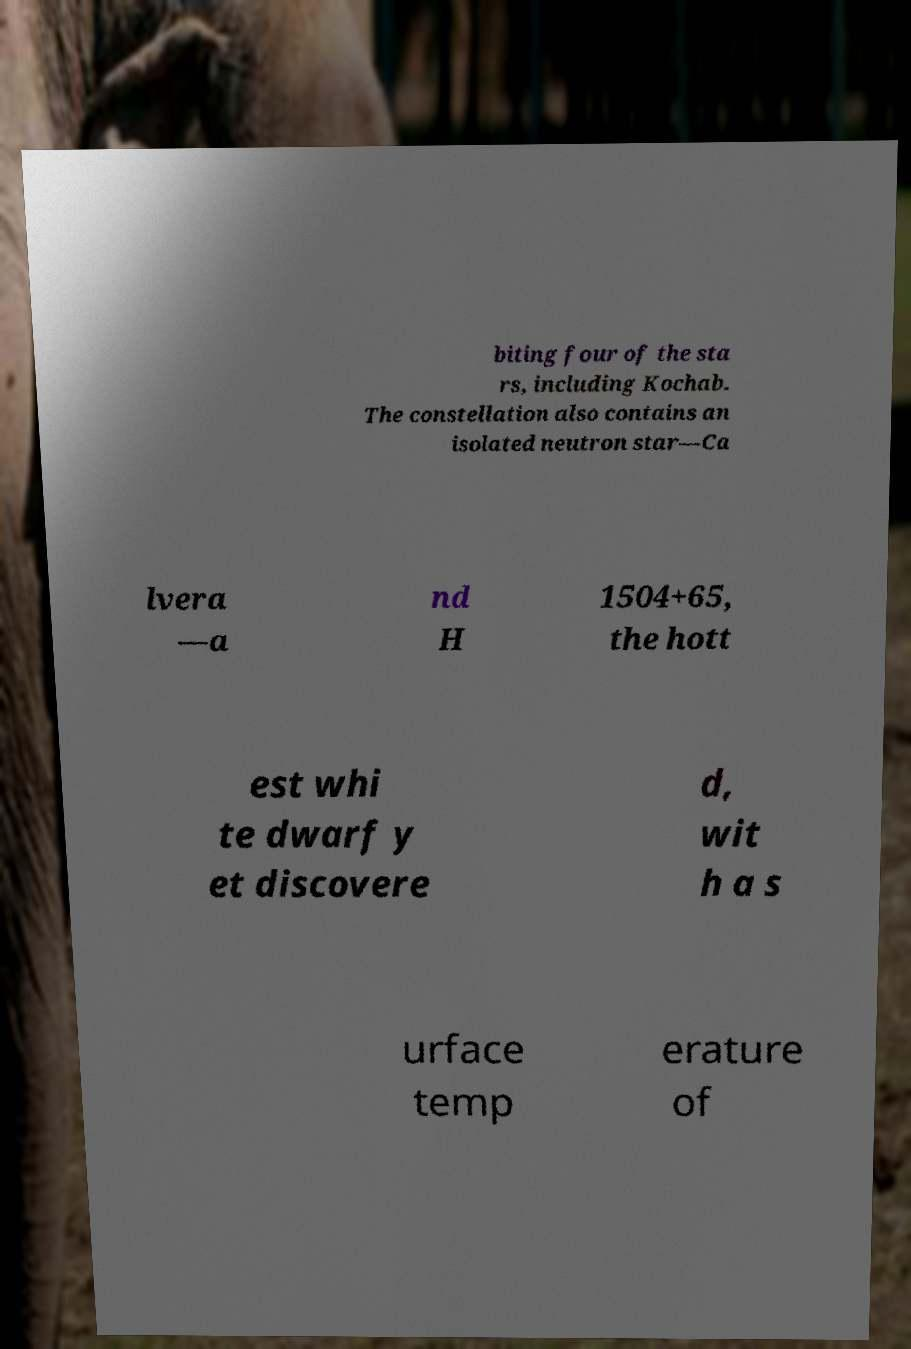I need the written content from this picture converted into text. Can you do that? biting four of the sta rs, including Kochab. The constellation also contains an isolated neutron star—Ca lvera —a nd H 1504+65, the hott est whi te dwarf y et discovere d, wit h a s urface temp erature of 